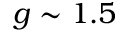Convert formula to latex. <formula><loc_0><loc_0><loc_500><loc_500>g \sim 1 . 5</formula> 